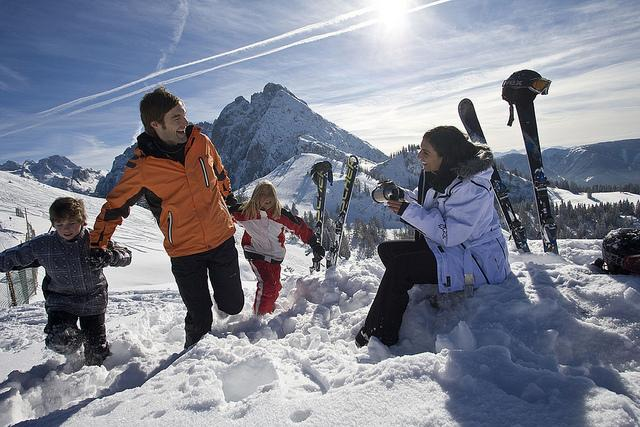What would be the most appropriate beverage for the family to have? Please explain your reasoning. coffee. Coffee would be a hot beverage which is suitable to drink when it's cold out. 